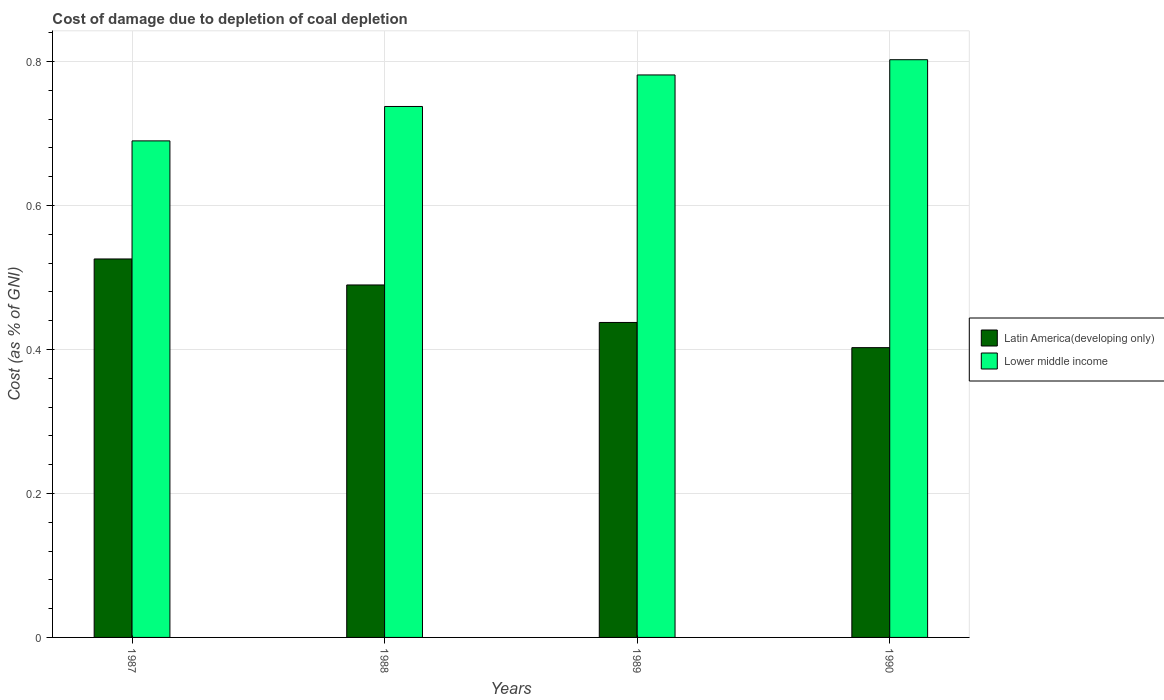How many groups of bars are there?
Ensure brevity in your answer.  4. Are the number of bars per tick equal to the number of legend labels?
Offer a terse response. Yes. How many bars are there on the 2nd tick from the left?
Your response must be concise. 2. What is the cost of damage caused due to coal depletion in Latin America(developing only) in 1990?
Make the answer very short. 0.4. Across all years, what is the maximum cost of damage caused due to coal depletion in Latin America(developing only)?
Make the answer very short. 0.53. Across all years, what is the minimum cost of damage caused due to coal depletion in Lower middle income?
Offer a very short reply. 0.69. In which year was the cost of damage caused due to coal depletion in Lower middle income minimum?
Your answer should be very brief. 1987. What is the total cost of damage caused due to coal depletion in Lower middle income in the graph?
Give a very brief answer. 3.01. What is the difference between the cost of damage caused due to coal depletion in Latin America(developing only) in 1987 and that in 1990?
Ensure brevity in your answer.  0.12. What is the difference between the cost of damage caused due to coal depletion in Lower middle income in 1989 and the cost of damage caused due to coal depletion in Latin America(developing only) in 1990?
Your answer should be compact. 0.38. What is the average cost of damage caused due to coal depletion in Latin America(developing only) per year?
Give a very brief answer. 0.46. In the year 1988, what is the difference between the cost of damage caused due to coal depletion in Lower middle income and cost of damage caused due to coal depletion in Latin America(developing only)?
Your response must be concise. 0.25. What is the ratio of the cost of damage caused due to coal depletion in Latin America(developing only) in 1988 to that in 1990?
Offer a terse response. 1.22. What is the difference between the highest and the second highest cost of damage caused due to coal depletion in Latin America(developing only)?
Your answer should be very brief. 0.04. What is the difference between the highest and the lowest cost of damage caused due to coal depletion in Latin America(developing only)?
Offer a very short reply. 0.12. In how many years, is the cost of damage caused due to coal depletion in Lower middle income greater than the average cost of damage caused due to coal depletion in Lower middle income taken over all years?
Your answer should be very brief. 2. Is the sum of the cost of damage caused due to coal depletion in Lower middle income in 1987 and 1990 greater than the maximum cost of damage caused due to coal depletion in Latin America(developing only) across all years?
Provide a short and direct response. Yes. What does the 2nd bar from the left in 1988 represents?
Keep it short and to the point. Lower middle income. What does the 2nd bar from the right in 1990 represents?
Your answer should be compact. Latin America(developing only). Are all the bars in the graph horizontal?
Ensure brevity in your answer.  No. How many years are there in the graph?
Make the answer very short. 4. How are the legend labels stacked?
Offer a terse response. Vertical. What is the title of the graph?
Provide a succinct answer. Cost of damage due to depletion of coal depletion. Does "Ecuador" appear as one of the legend labels in the graph?
Give a very brief answer. No. What is the label or title of the Y-axis?
Ensure brevity in your answer.  Cost (as % of GNI). What is the Cost (as % of GNI) of Latin America(developing only) in 1987?
Your answer should be compact. 0.53. What is the Cost (as % of GNI) in Lower middle income in 1987?
Offer a terse response. 0.69. What is the Cost (as % of GNI) in Latin America(developing only) in 1988?
Your response must be concise. 0.49. What is the Cost (as % of GNI) in Lower middle income in 1988?
Your answer should be very brief. 0.74. What is the Cost (as % of GNI) of Latin America(developing only) in 1989?
Your answer should be very brief. 0.44. What is the Cost (as % of GNI) in Lower middle income in 1989?
Your response must be concise. 0.78. What is the Cost (as % of GNI) in Latin America(developing only) in 1990?
Offer a terse response. 0.4. What is the Cost (as % of GNI) in Lower middle income in 1990?
Offer a very short reply. 0.8. Across all years, what is the maximum Cost (as % of GNI) in Latin America(developing only)?
Provide a succinct answer. 0.53. Across all years, what is the maximum Cost (as % of GNI) of Lower middle income?
Provide a short and direct response. 0.8. Across all years, what is the minimum Cost (as % of GNI) in Latin America(developing only)?
Your answer should be compact. 0.4. Across all years, what is the minimum Cost (as % of GNI) of Lower middle income?
Ensure brevity in your answer.  0.69. What is the total Cost (as % of GNI) of Latin America(developing only) in the graph?
Provide a short and direct response. 1.86. What is the total Cost (as % of GNI) of Lower middle income in the graph?
Your response must be concise. 3.01. What is the difference between the Cost (as % of GNI) in Latin America(developing only) in 1987 and that in 1988?
Ensure brevity in your answer.  0.04. What is the difference between the Cost (as % of GNI) of Lower middle income in 1987 and that in 1988?
Give a very brief answer. -0.05. What is the difference between the Cost (as % of GNI) of Latin America(developing only) in 1987 and that in 1989?
Provide a succinct answer. 0.09. What is the difference between the Cost (as % of GNI) in Lower middle income in 1987 and that in 1989?
Provide a succinct answer. -0.09. What is the difference between the Cost (as % of GNI) of Latin America(developing only) in 1987 and that in 1990?
Your response must be concise. 0.12. What is the difference between the Cost (as % of GNI) in Lower middle income in 1987 and that in 1990?
Your answer should be very brief. -0.11. What is the difference between the Cost (as % of GNI) of Latin America(developing only) in 1988 and that in 1989?
Your answer should be very brief. 0.05. What is the difference between the Cost (as % of GNI) of Lower middle income in 1988 and that in 1989?
Keep it short and to the point. -0.04. What is the difference between the Cost (as % of GNI) of Latin America(developing only) in 1988 and that in 1990?
Your answer should be very brief. 0.09. What is the difference between the Cost (as % of GNI) in Lower middle income in 1988 and that in 1990?
Ensure brevity in your answer.  -0.07. What is the difference between the Cost (as % of GNI) of Latin America(developing only) in 1989 and that in 1990?
Your answer should be very brief. 0.04. What is the difference between the Cost (as % of GNI) of Lower middle income in 1989 and that in 1990?
Offer a terse response. -0.02. What is the difference between the Cost (as % of GNI) in Latin America(developing only) in 1987 and the Cost (as % of GNI) in Lower middle income in 1988?
Provide a short and direct response. -0.21. What is the difference between the Cost (as % of GNI) in Latin America(developing only) in 1987 and the Cost (as % of GNI) in Lower middle income in 1989?
Keep it short and to the point. -0.26. What is the difference between the Cost (as % of GNI) in Latin America(developing only) in 1987 and the Cost (as % of GNI) in Lower middle income in 1990?
Your answer should be very brief. -0.28. What is the difference between the Cost (as % of GNI) in Latin America(developing only) in 1988 and the Cost (as % of GNI) in Lower middle income in 1989?
Offer a terse response. -0.29. What is the difference between the Cost (as % of GNI) of Latin America(developing only) in 1988 and the Cost (as % of GNI) of Lower middle income in 1990?
Offer a terse response. -0.31. What is the difference between the Cost (as % of GNI) in Latin America(developing only) in 1989 and the Cost (as % of GNI) in Lower middle income in 1990?
Provide a succinct answer. -0.37. What is the average Cost (as % of GNI) in Latin America(developing only) per year?
Keep it short and to the point. 0.46. What is the average Cost (as % of GNI) of Lower middle income per year?
Your answer should be compact. 0.75. In the year 1987, what is the difference between the Cost (as % of GNI) in Latin America(developing only) and Cost (as % of GNI) in Lower middle income?
Offer a terse response. -0.16. In the year 1988, what is the difference between the Cost (as % of GNI) in Latin America(developing only) and Cost (as % of GNI) in Lower middle income?
Your answer should be very brief. -0.25. In the year 1989, what is the difference between the Cost (as % of GNI) in Latin America(developing only) and Cost (as % of GNI) in Lower middle income?
Your response must be concise. -0.34. In the year 1990, what is the difference between the Cost (as % of GNI) in Latin America(developing only) and Cost (as % of GNI) in Lower middle income?
Make the answer very short. -0.4. What is the ratio of the Cost (as % of GNI) in Latin America(developing only) in 1987 to that in 1988?
Provide a succinct answer. 1.07. What is the ratio of the Cost (as % of GNI) in Lower middle income in 1987 to that in 1988?
Your response must be concise. 0.94. What is the ratio of the Cost (as % of GNI) in Latin America(developing only) in 1987 to that in 1989?
Ensure brevity in your answer.  1.2. What is the ratio of the Cost (as % of GNI) of Lower middle income in 1987 to that in 1989?
Offer a very short reply. 0.88. What is the ratio of the Cost (as % of GNI) of Latin America(developing only) in 1987 to that in 1990?
Your response must be concise. 1.31. What is the ratio of the Cost (as % of GNI) of Lower middle income in 1987 to that in 1990?
Offer a terse response. 0.86. What is the ratio of the Cost (as % of GNI) of Latin America(developing only) in 1988 to that in 1989?
Offer a very short reply. 1.12. What is the ratio of the Cost (as % of GNI) in Lower middle income in 1988 to that in 1989?
Provide a succinct answer. 0.94. What is the ratio of the Cost (as % of GNI) of Latin America(developing only) in 1988 to that in 1990?
Your answer should be very brief. 1.22. What is the ratio of the Cost (as % of GNI) of Lower middle income in 1988 to that in 1990?
Your answer should be very brief. 0.92. What is the ratio of the Cost (as % of GNI) of Latin America(developing only) in 1989 to that in 1990?
Offer a terse response. 1.09. What is the ratio of the Cost (as % of GNI) in Lower middle income in 1989 to that in 1990?
Ensure brevity in your answer.  0.97. What is the difference between the highest and the second highest Cost (as % of GNI) in Latin America(developing only)?
Your response must be concise. 0.04. What is the difference between the highest and the second highest Cost (as % of GNI) of Lower middle income?
Your answer should be very brief. 0.02. What is the difference between the highest and the lowest Cost (as % of GNI) in Latin America(developing only)?
Offer a very short reply. 0.12. What is the difference between the highest and the lowest Cost (as % of GNI) in Lower middle income?
Provide a short and direct response. 0.11. 